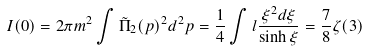<formula> <loc_0><loc_0><loc_500><loc_500>I ( 0 ) = 2 \pi m ^ { 2 } \int \tilde { \Pi } _ { 2 } ( p ) ^ { 2 } d ^ { 2 } p = \frac { 1 } { 4 } \int l \frac { \xi ^ { 2 } d \xi } { \sinh \xi } = \frac { 7 } { 8 } \zeta ( 3 )</formula> 